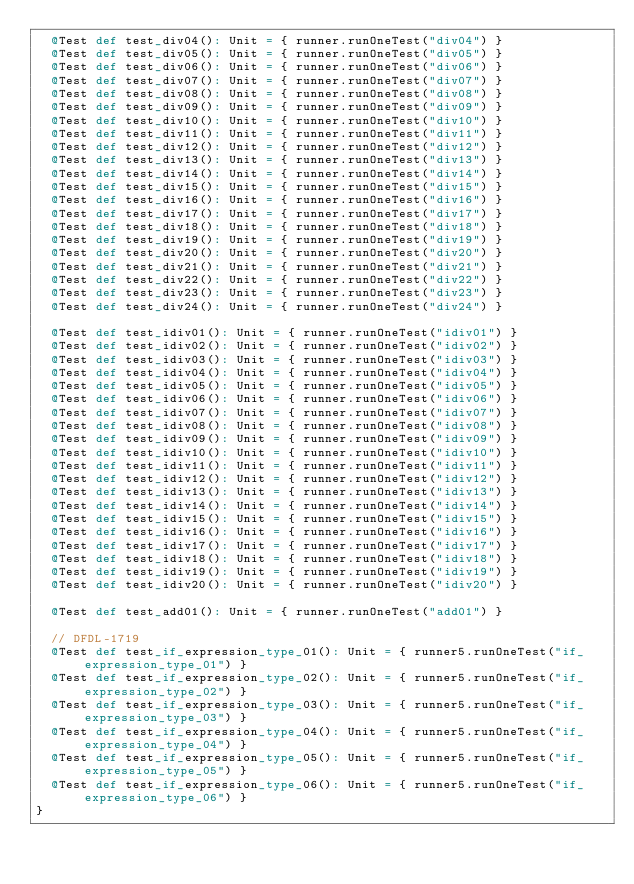Convert code to text. <code><loc_0><loc_0><loc_500><loc_500><_Scala_>  @Test def test_div04(): Unit = { runner.runOneTest("div04") }
  @Test def test_div05(): Unit = { runner.runOneTest("div05") }
  @Test def test_div06(): Unit = { runner.runOneTest("div06") }
  @Test def test_div07(): Unit = { runner.runOneTest("div07") }
  @Test def test_div08(): Unit = { runner.runOneTest("div08") }
  @Test def test_div09(): Unit = { runner.runOneTest("div09") }
  @Test def test_div10(): Unit = { runner.runOneTest("div10") }
  @Test def test_div11(): Unit = { runner.runOneTest("div11") }
  @Test def test_div12(): Unit = { runner.runOneTest("div12") }
  @Test def test_div13(): Unit = { runner.runOneTest("div13") }
  @Test def test_div14(): Unit = { runner.runOneTest("div14") }
  @Test def test_div15(): Unit = { runner.runOneTest("div15") }
  @Test def test_div16(): Unit = { runner.runOneTest("div16") }
  @Test def test_div17(): Unit = { runner.runOneTest("div17") }
  @Test def test_div18(): Unit = { runner.runOneTest("div18") }
  @Test def test_div19(): Unit = { runner.runOneTest("div19") }
  @Test def test_div20(): Unit = { runner.runOneTest("div20") }
  @Test def test_div21(): Unit = { runner.runOneTest("div21") }
  @Test def test_div22(): Unit = { runner.runOneTest("div22") }
  @Test def test_div23(): Unit = { runner.runOneTest("div23") }
  @Test def test_div24(): Unit = { runner.runOneTest("div24") }

  @Test def test_idiv01(): Unit = { runner.runOneTest("idiv01") }
  @Test def test_idiv02(): Unit = { runner.runOneTest("idiv02") }
  @Test def test_idiv03(): Unit = { runner.runOneTest("idiv03") }
  @Test def test_idiv04(): Unit = { runner.runOneTest("idiv04") }
  @Test def test_idiv05(): Unit = { runner.runOneTest("idiv05") }
  @Test def test_idiv06(): Unit = { runner.runOneTest("idiv06") }
  @Test def test_idiv07(): Unit = { runner.runOneTest("idiv07") }
  @Test def test_idiv08(): Unit = { runner.runOneTest("idiv08") }
  @Test def test_idiv09(): Unit = { runner.runOneTest("idiv09") }
  @Test def test_idiv10(): Unit = { runner.runOneTest("idiv10") }
  @Test def test_idiv11(): Unit = { runner.runOneTest("idiv11") }
  @Test def test_idiv12(): Unit = { runner.runOneTest("idiv12") }
  @Test def test_idiv13(): Unit = { runner.runOneTest("idiv13") }
  @Test def test_idiv14(): Unit = { runner.runOneTest("idiv14") }
  @Test def test_idiv15(): Unit = { runner.runOneTest("idiv15") }
  @Test def test_idiv16(): Unit = { runner.runOneTest("idiv16") }
  @Test def test_idiv17(): Unit = { runner.runOneTest("idiv17") }
  @Test def test_idiv18(): Unit = { runner.runOneTest("idiv18") }
  @Test def test_idiv19(): Unit = { runner.runOneTest("idiv19") }
  @Test def test_idiv20(): Unit = { runner.runOneTest("idiv20") }

  @Test def test_add01(): Unit = { runner.runOneTest("add01") }

  // DFDL-1719
  @Test def test_if_expression_type_01(): Unit = { runner5.runOneTest("if_expression_type_01") }
  @Test def test_if_expression_type_02(): Unit = { runner5.runOneTest("if_expression_type_02") }
  @Test def test_if_expression_type_03(): Unit = { runner5.runOneTest("if_expression_type_03") }
  @Test def test_if_expression_type_04(): Unit = { runner5.runOneTest("if_expression_type_04") }
  @Test def test_if_expression_type_05(): Unit = { runner5.runOneTest("if_expression_type_05") }
  @Test def test_if_expression_type_06(): Unit = { runner5.runOneTest("if_expression_type_06") }
}
</code> 